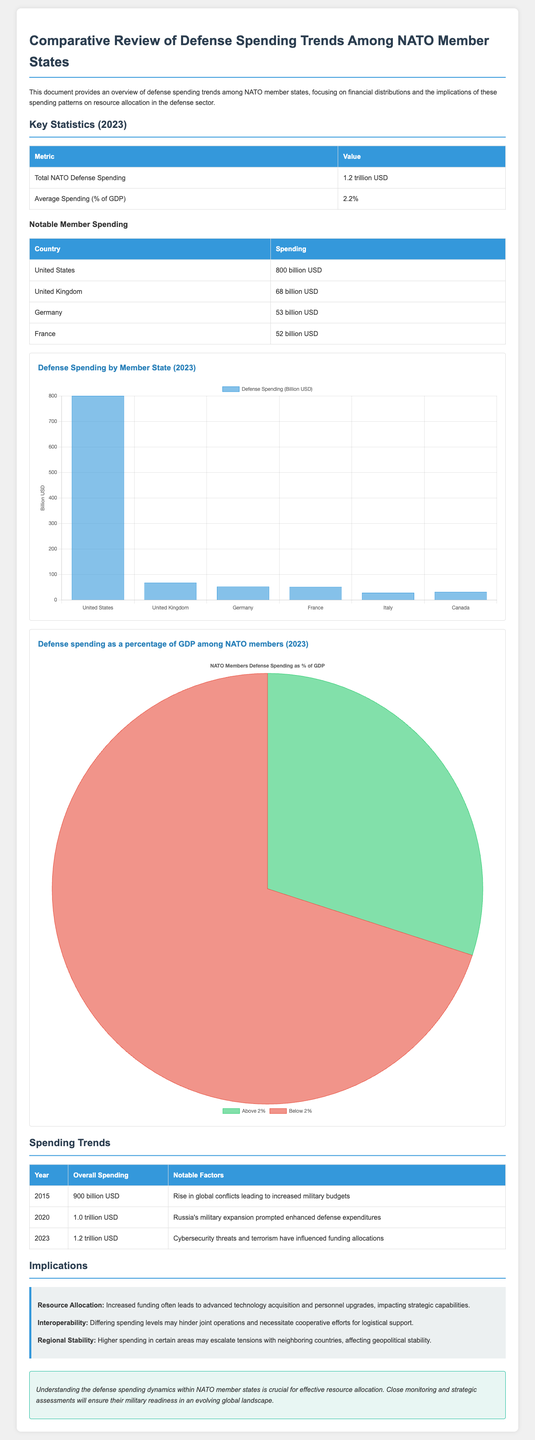What is the total NATO defense spending? The total NATO defense spending is given in the document as 1.2 trillion USD.
Answer: 1.2 trillion USD What percentage of GDP is the average spending among NATO members? The average spending as a percentage of GDP is explicitly stated in the document as 2.2%.
Answer: 2.2% Which country has the highest defense spending? The document lists the United States as having the highest defense spending at 800 billion USD.
Answer: United States What significant factor influenced spending trends from 2020 to 2023? The rise in cybersecurity threats and terrorism is indicated as a notable factor influencing funding allocations from 2020 to 2023.
Answer: Cybersecurity threats and terrorism How much does Germany spend on defense in 2023? The document provides a specific amount for Germany's defense spending which is 53 billion USD.
Answer: 53 billion USD What is the implication of increased funding according to the document? The document states that increased funding often leads to advanced technology acquisition and personnel upgrades, impacting strategic capabilities.
Answer: Advanced technology acquisition How many NATO members have defense spending below 2% of GDP? The document indicates that 70% of NATO members spend below 2% of their GDP, implying that 70% are below this threshold.
Answer: 70% What was the total defense spending in 2015? The document specifies that the overall defense spending in 2015 was 900 billion USD.
Answer: 900 billion USD What key trend is observed from 2015 to 2023? The document shows an overall increase in defense spending, highlighting the year-to-year rise due to various factors.
Answer: Increase in defense spending 